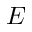Convert formula to latex. <formula><loc_0><loc_0><loc_500><loc_500>E</formula> 